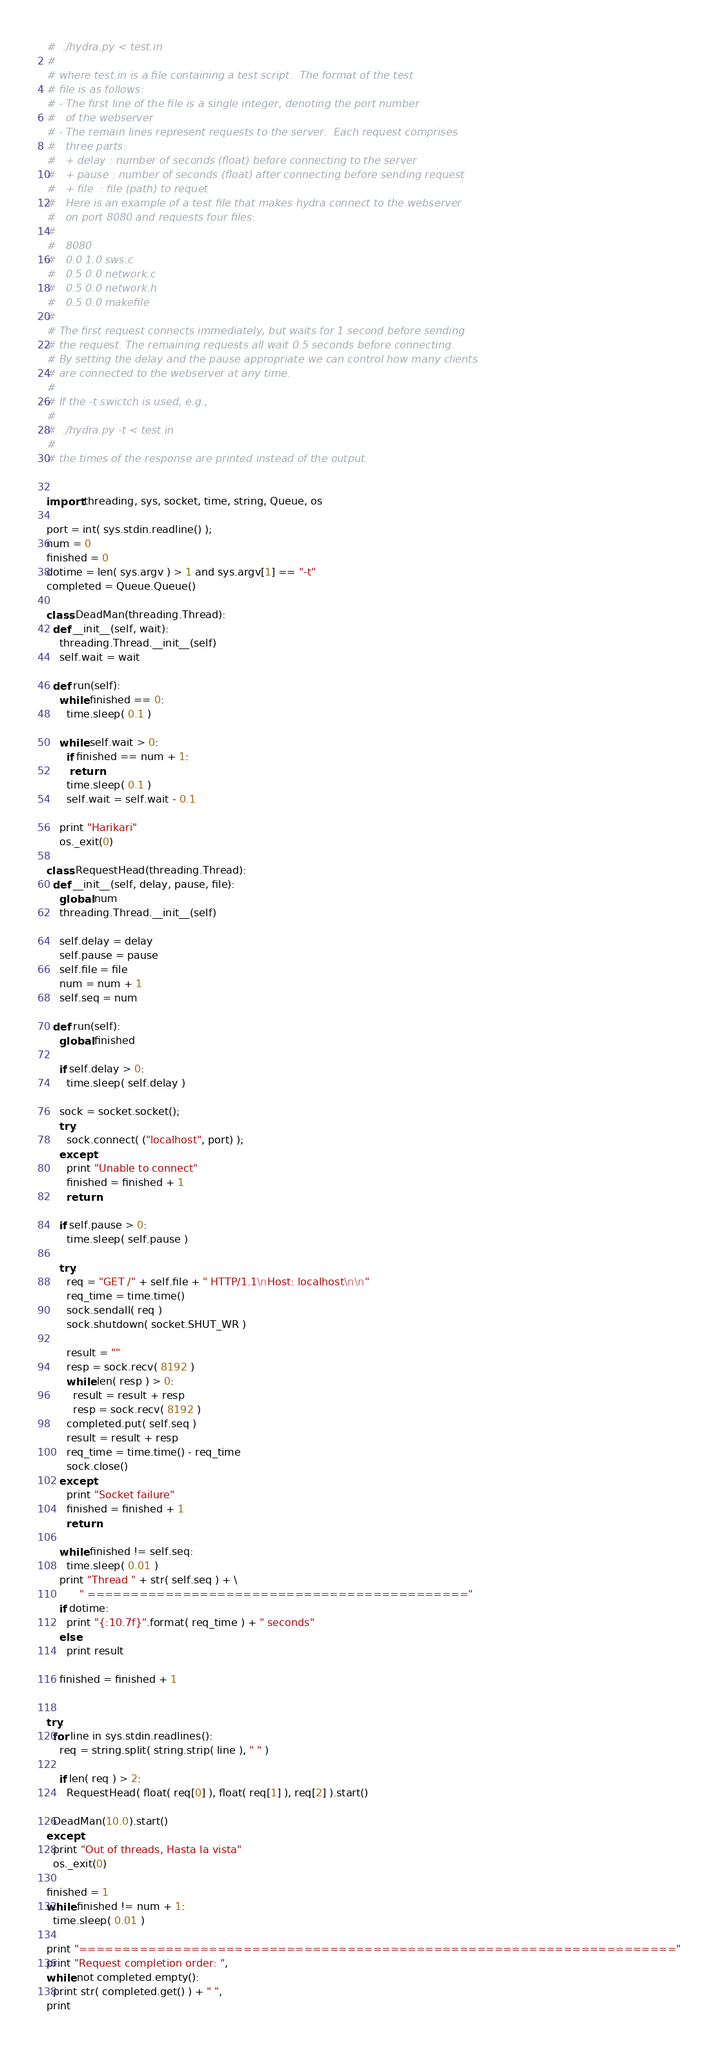Convert code to text. <code><loc_0><loc_0><loc_500><loc_500><_Python_>#  ./hydra.py < test.in
#
# where test.in is a file containing a test script.  The format of the test
# file is as follows:
# - The first line of the file is a single integer, denoting the port number
#   of the webserver
# - The remain lines represent requests to the server.  Each request comprises
#   three parts:
#   + delay : number of seconds (float) before connecting to the server
#   + pause : number of seconds (float) after connecting before sending request
#   + file  : file (path) to requet
#   Here is an example of a test file that makes hydra connect to the webserver
#   on port 8080 and requests four files:
#
#   8080
#   0.0 1.0 sws.c
#   0.5 0.0 network.c
#   0.5 0.0 network.h
#   0.5 0.0 makefile
#
# The first request connects immediately, but waits for 1 second before sending
# the request. The remaining requests all wait 0.5 seconds before connecting.
# By setting the delay and the pause appropriate we can control how many clients
# are connected to the webserver at any time.
#
# If the -t swictch is used, e.g.,
#
#  ./hydra.py -t < test.in
#
# the times of the response are printed instead of the output.


import threading, sys, socket, time, string, Queue, os

port = int( sys.stdin.readline() );
num = 0
finished = 0
dotime = len( sys.argv ) > 1 and sys.argv[1] == "-t"
completed = Queue.Queue()

class DeadMan(threading.Thread):
  def __init__(self, wait):
    threading.Thread.__init__(self)
    self.wait = wait

  def run(self):
    while finished == 0:
      time.sleep( 0.1 )

    while self.wait > 0:
      if finished == num + 1:
       return
      time.sleep( 0.1 )
      self.wait = self.wait - 0.1

    print "Harikari"
    os._exit(0)

class RequestHead(threading.Thread):
  def __init__(self, delay, pause, file):
    global num
    threading.Thread.__init__(self)

    self.delay = delay
    self.pause = pause
    self.file = file
    num = num + 1
    self.seq = num

  def run(self):
    global finished

    if self.delay > 0:
      time.sleep( self.delay )

    sock = socket.socket();
    try: 
      sock.connect( ("localhost", port) );
    except:
      print "Unable to connect"
      finished = finished + 1
      return

    if self.pause > 0:
      time.sleep( self.pause )

    try: 
      req = "GET /" + self.file + " HTTP/1.1\nHost: localhost\n\n" 
      req_time = time.time()
      sock.sendall( req )
      sock.shutdown( socket.SHUT_WR )

      result = ""
      resp = sock.recv( 8192 )
      while len( resp ) > 0:
        result = result + resp
        resp = sock.recv( 8192 )
      completed.put( self.seq )
      result = result + resp
      req_time = time.time() - req_time
      sock.close()
    except:
      print "Socket failure"
      finished = finished + 1
      return

    while finished != self.seq:
      time.sleep( 0.01 )
    print "Thread " + str( self.seq ) + \
          " ============================================"
    if dotime:
      print "{:10.7f}".format( req_time ) + " seconds"
    else:
      print result

    finished = finished + 1

      
try:
  for line in sys.stdin.readlines():
    req = string.split( string.strip( line ), " " )

    if len( req ) > 2:
      RequestHead( float( req[0] ), float( req[1] ), req[2] ).start()

  DeadMan(10.0).start()
except:
  print "Out of threads, Hasta la vista"
  os._exit(0)

finished = 1
while finished != num + 1:
  time.sleep( 0.01 )

print "====================================================================="
print "Request completion order: ",
while not completed.empty():
  print str( completed.get() ) + " ",
print
</code> 